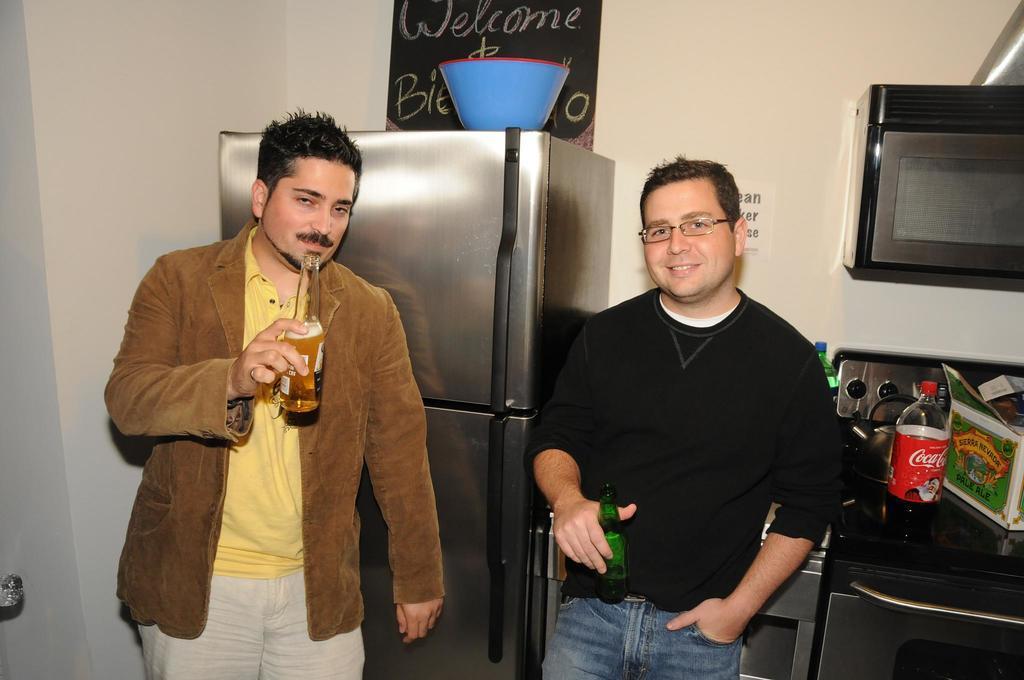Describe this image in one or two sentences. In this picture, There are two persons standing and they are holding bottles, In the right side there is a table which is black color and in the middle there is a fridge which is in ash color, In the background there is a board which is in black color. 